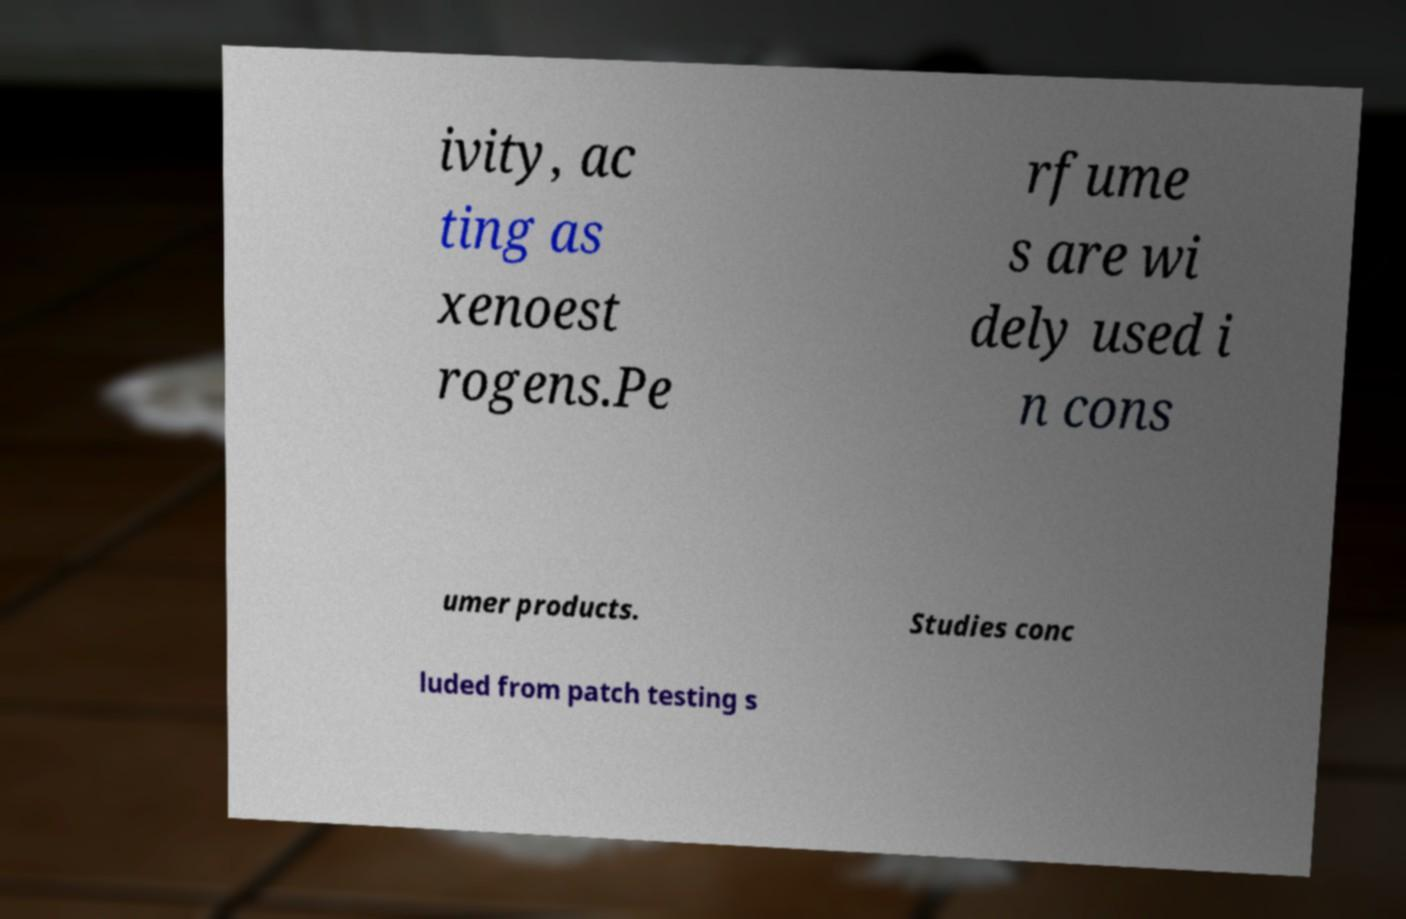Could you extract and type out the text from this image? ivity, ac ting as xenoest rogens.Pe rfume s are wi dely used i n cons umer products. Studies conc luded from patch testing s 